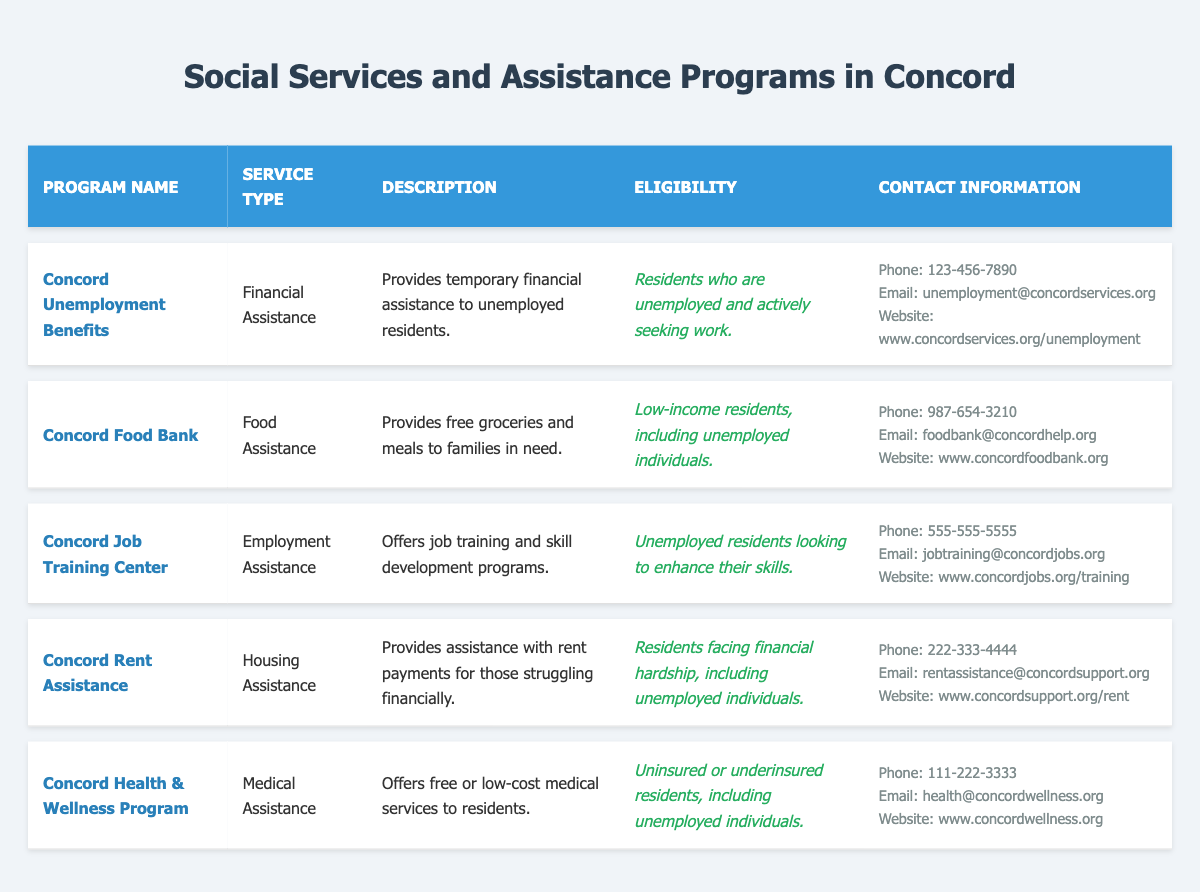What is the program that provides temporary financial assistance to unemployed residents? The table lists "Concord Unemployment Benefits" under the Program Name column, where it specifies that it provides temporary financial assistance to unemployed residents.
Answer: Concord Unemployment Benefits Which program offers job training and skill development? Looking at the table, "Concord Job Training Center" is mentioned as the program that offers job training and skill development programs.
Answer: Concord Job Training Center Are there any programs that provide housing assistance? In the table, "Concord Rent Assistance" is listed under the Service Type as Housing Assistance, meaning it provides support with rent payments for struggling residents.
Answer: Yes Which program has the contact phone number 987-654-3210? Checking the contact information in the table, the phone number 987-654-3210 corresponds to the "Concord Food Bank" program.
Answer: Concord Food Bank How many programs offer assistance to unemployed residents? By reviewing the table, "Concord Unemployment Benefits," "Concord Job Training Center," "Concord Rent Assistance," and "Concord Health & Wellness Program" all assist unemployed residents. Thus, there are four programs that cater to their needs.
Answer: 4 Are all assistance programs in the table available to unemployed individuals? Analyzing the eligibility criteria listed in the table, we find that "Concord Food Bank,” "Concord Job Training Center," "Concord Rent Assistance," and "Concord Health & Wellness Program" specifically mention unemployed individuals. The only program that does not explicitly state this criterion is the "Concord Unemployment Benefits." Therefore, not all programs are available to unemployed individuals.
Answer: No What is the primary service type of the "Concord Food Bank" program? The table states under the Service Type column that the "Concord Food Bank" provides Food Assistance.
Answer: Food Assistance List the programs that offer financial assistance and their corresponding eligibility criteria. Upon examining the table, two programs offer financial assistance: "Concord Unemployment Benefits" with eligibility for unemployed residents actively seeking work, and "Concord Rent Assistance," which is available to residents facing financial hardship, including unemployed individuals.
Answer: Concord Unemployment Benefits; Residents who are unemployed and actively seeking work; Concord Rent Assistance; Residents facing financial hardship, including unemployed individuals Which program offers free or low-cost medical services? According to the table, the "Concord Health & Wellness Program" is the program that offers free or low-cost medical services to residents.
Answer: Concord Health & Wellness Program 